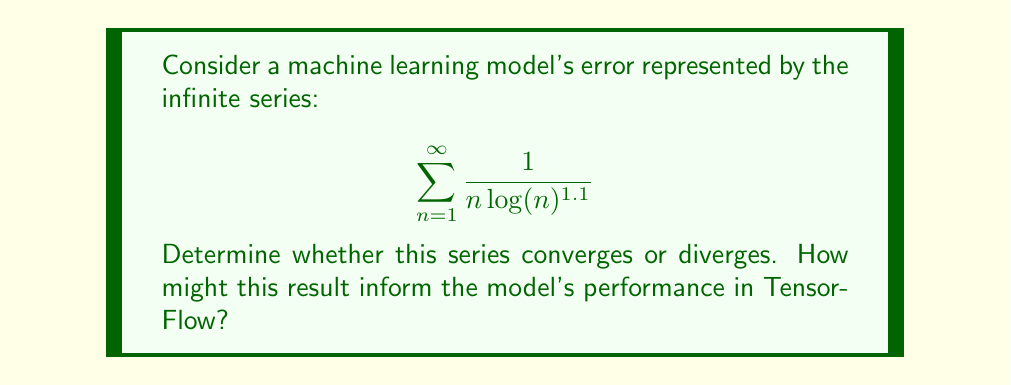Can you solve this math problem? To determine the convergence of this series, we can use the integral test. Let's define the function:

$$ f(x) = \frac{1}{x \log(x)^{1.1}} $$

Step 1: Check if $f(x)$ is continuous, positive, and decreasing for $x \geq 2$.
- $f(x)$ is continuous for $x > 1$
- $f(x)$ is positive for $x > 1$
- $f'(x) = -\frac{1.1\log(x)+1}{x^2\log(x)^{2.1}} < 0$ for $x > 1$, so $f(x)$ is decreasing

Step 2: Evaluate the improper integral:

$$ \int_2^{\infty} \frac{1}{x \log(x)^{1.1}} dx $$

Let $u = \log(x)$, then $du = \frac{1}{x}dx$, and $x = e^u$. The integral becomes:

$$ \int_{\log(2)}^{\infty} \frac{1}{u^{1.1}} du $$

This is a p-integral with $p = 1.1 > 1$, which converges.

Step 3: Apply the integral test
Since the improper integral converges, the original series also converges.

In the context of TensorFlow and machine learning, this result suggests that the model's error decreases at a rate that, when summed over infinite iterations, produces a finite total error. This implies that the model is capable of achieving a bounded total error, which is a positive indicator of its performance and potential for convergence during training.
Answer: The series $\sum_{n=1}^{\infty} \frac{1}{n \log(n)^{1.1}}$ converges. 